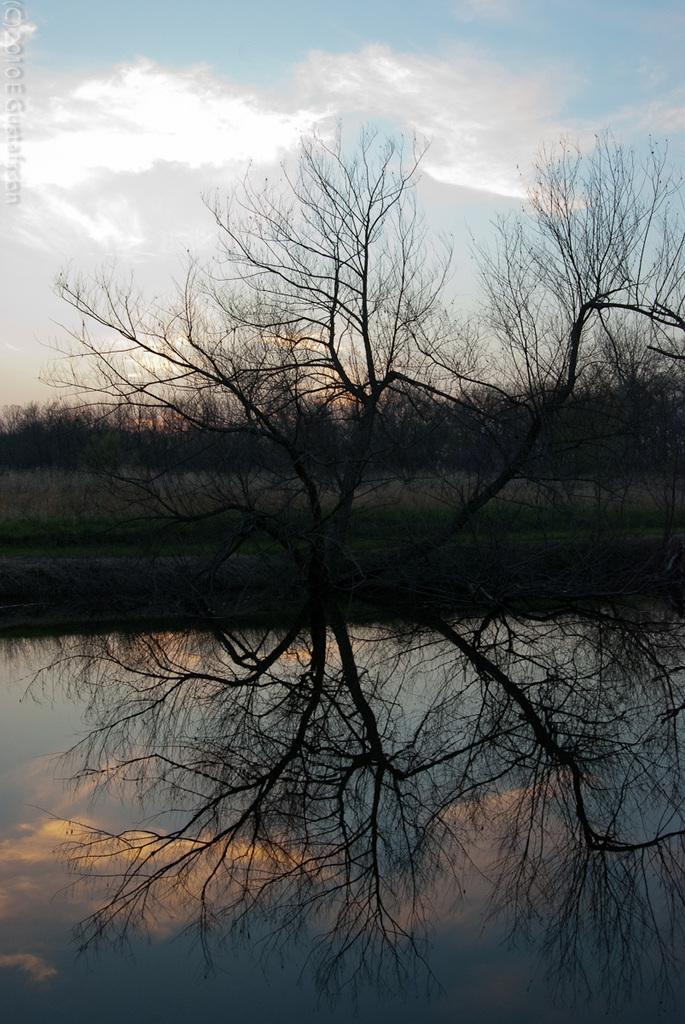What is one of the natural elements visible in the image? There is water in the image. What type of vegetation can be seen in the image? There are trees and grass in the image. What is visible in the background of the image? The sky is visible in the background of the image. What can be observed in the sky? Clouds are present in the sky. How does the rat transport the grass in the image? There is no rat present in the image, so it cannot be used to transport grass. 